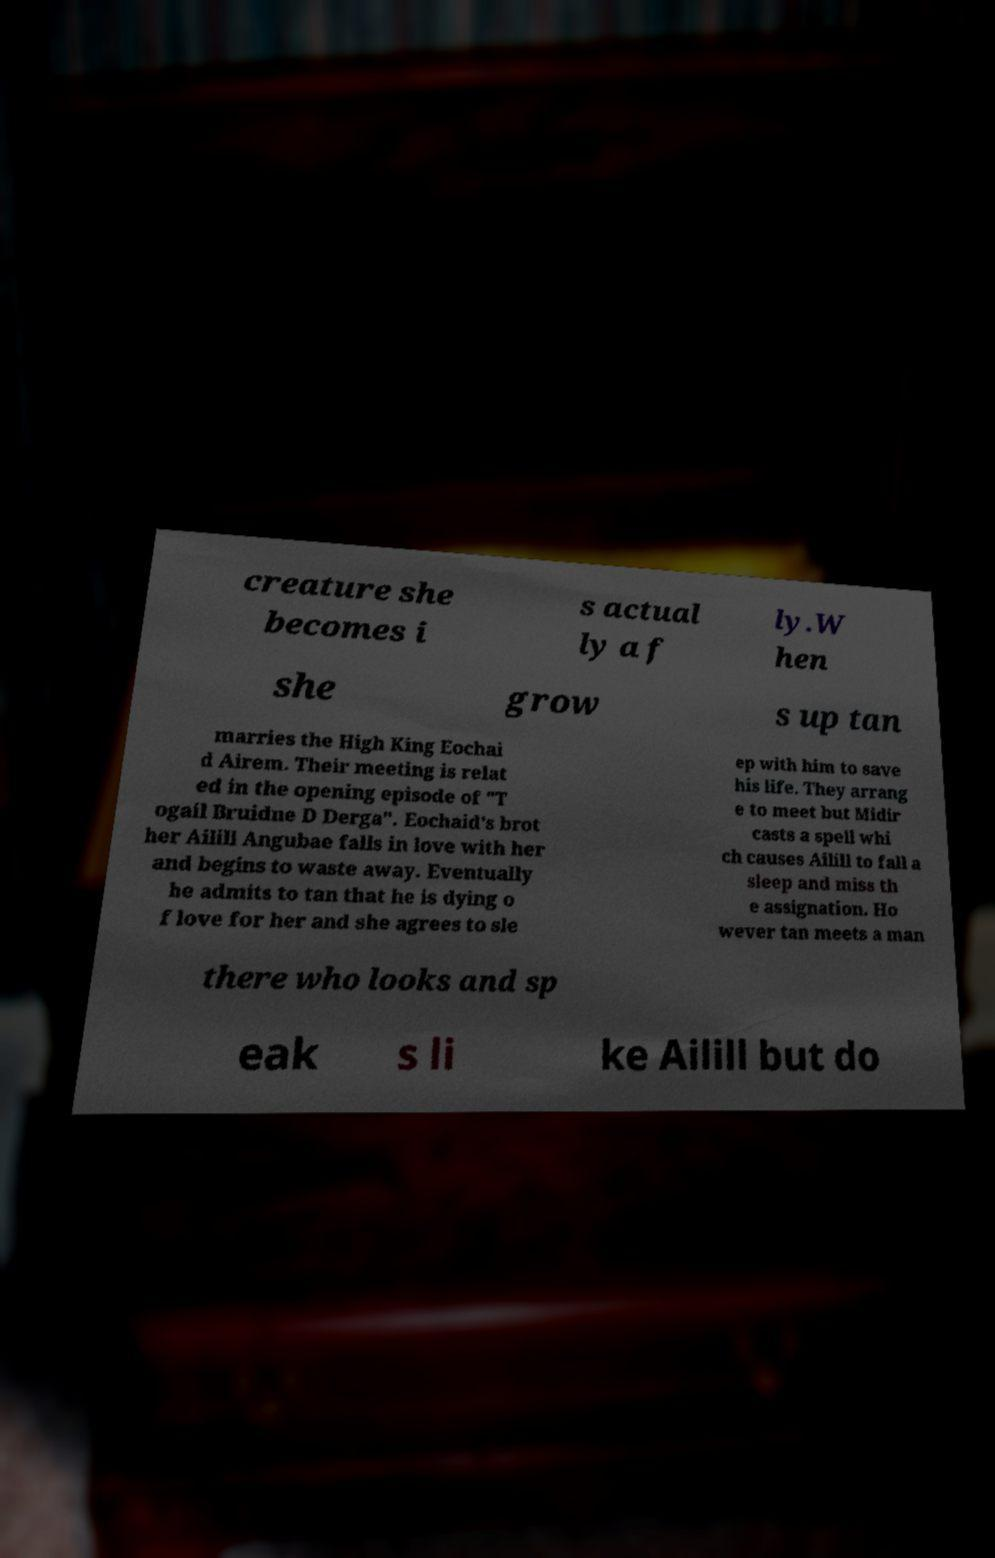Can you accurately transcribe the text from the provided image for me? creature she becomes i s actual ly a f ly.W hen she grow s up tan marries the High King Eochai d Airem. Their meeting is relat ed in the opening episode of "T ogail Bruidne D Derga". Eochaid's brot her Ailill Angubae falls in love with her and begins to waste away. Eventually he admits to tan that he is dying o f love for her and she agrees to sle ep with him to save his life. They arrang e to meet but Midir casts a spell whi ch causes Ailill to fall a sleep and miss th e assignation. Ho wever tan meets a man there who looks and sp eak s li ke Ailill but do 